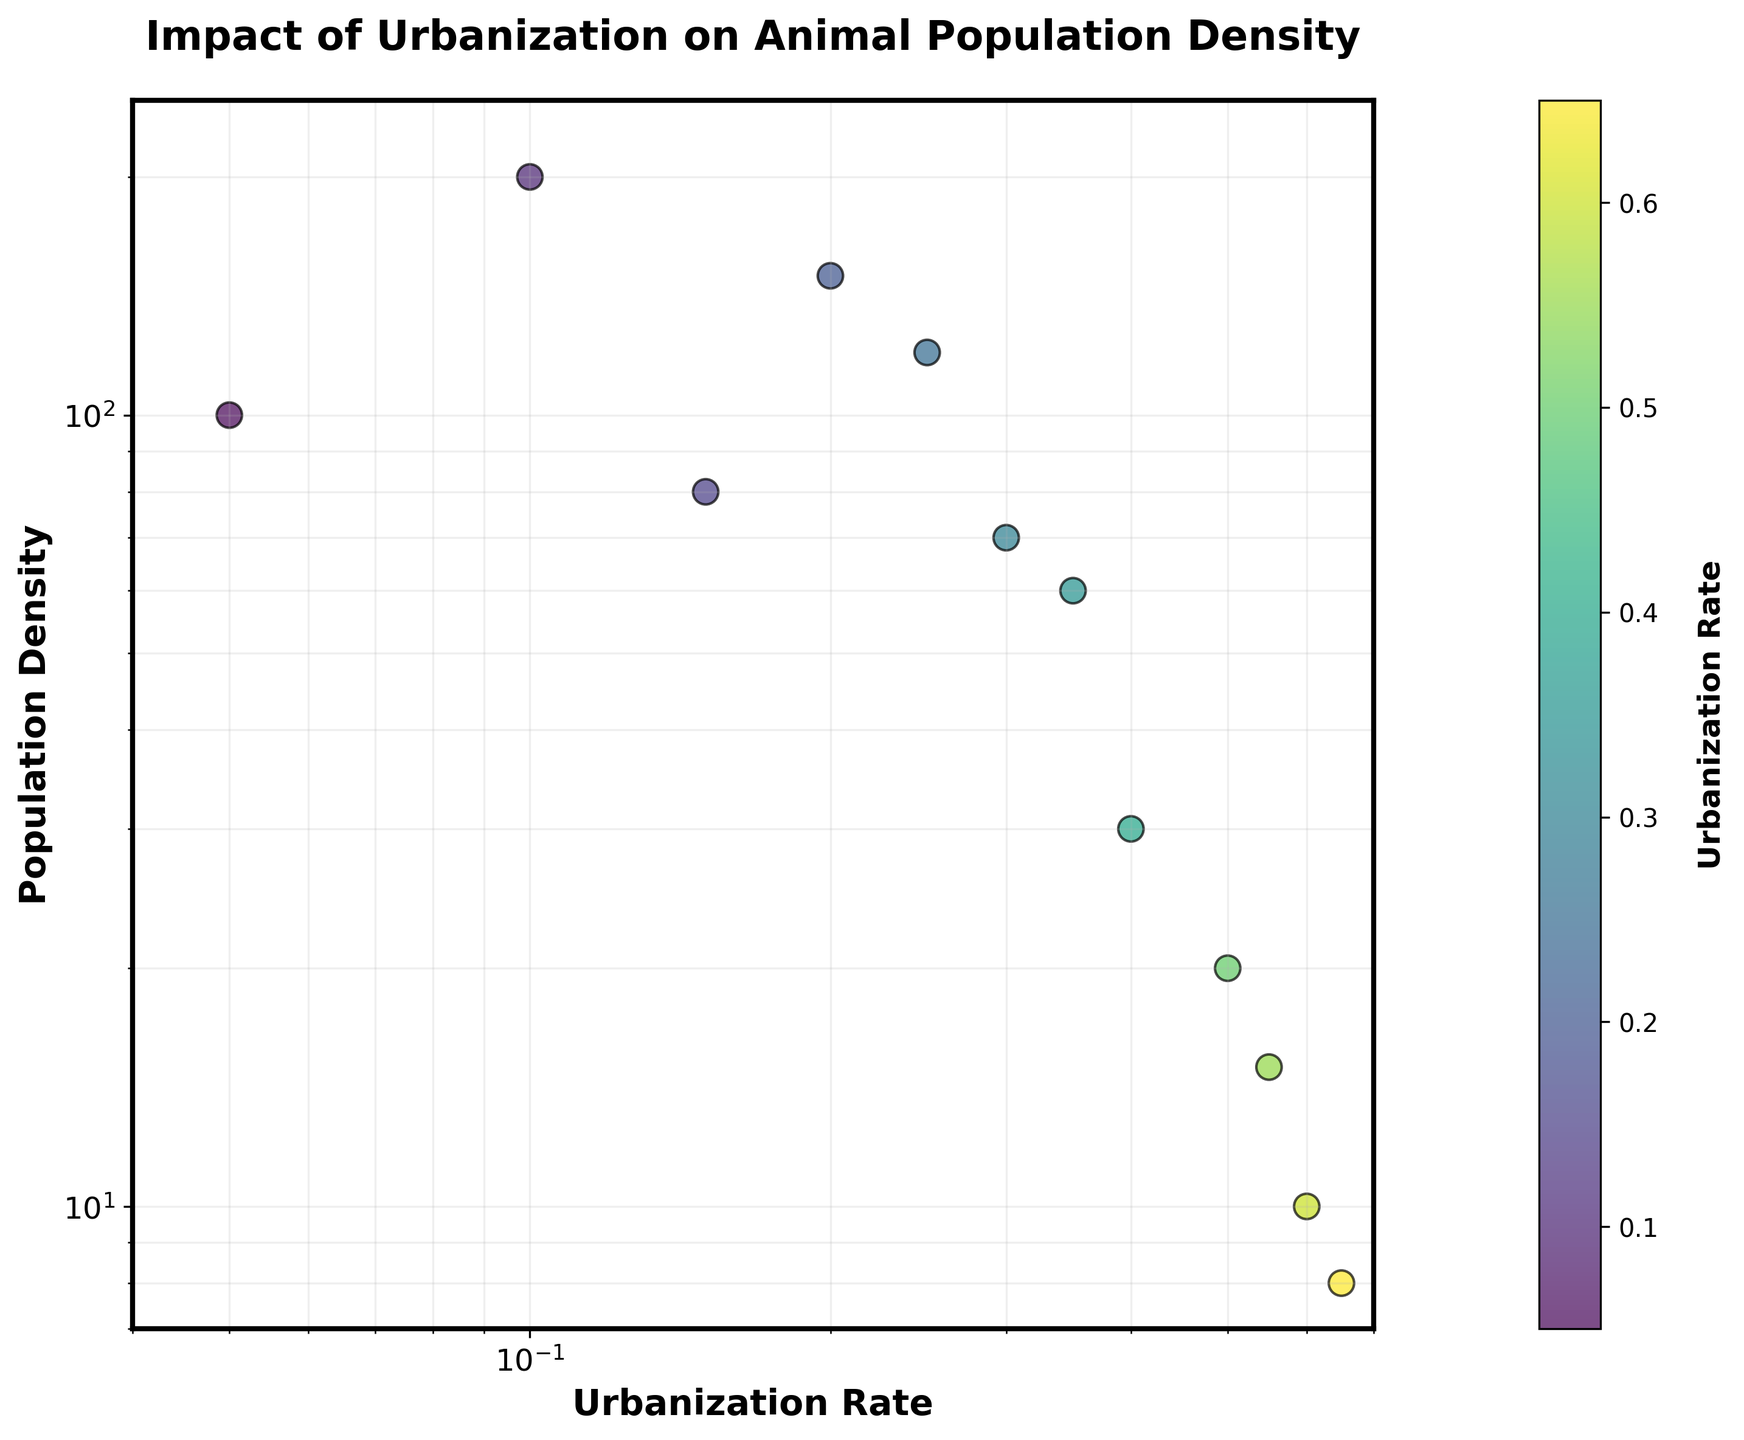What is the title of the plot? The title of the plot is located at the top center and reads "Impact of Urbanization on Animal Population Density."
Answer: "Impact of Urbanization on Animal Population Density" What is the x-axis label? The label on the x-axis is placed horizontally below the axis and reads "Urbanization Rate".
Answer: "Urbanization Rate" How many data points are represented in the scatter plot? To determine the number of data points, count each unique marker on the scatter plot. There are 12 data points represented.
Answer: 12 Which data point has the highest population density, and what is its urbanization rate? Look at the y-axis to find the highest population density, which is 200. Then, trace vertically downward to find the corresponding urbanization rate, which is 0.1.
Answer: Highest population density: 200, Urbanization rate: 0.1 Which data point has the lowest urbanization rate, and what is its population density? The lowest urbanization rate on the x-axis is 0.05. Trace vertically upward to find its corresponding population density, which is 100.
Answer: Lowest urbanization rate: 0.05, Population density: 100 Is there a visible trend between urbanization rates and population densities? The plot shows that as urbanization rates increase, population densities generally decrease. This is shown by the downward scattering of points from left to right.
Answer: Population densities decrease with increasing urbanization rates What is the population density at an urbanization rate of 0.3? Locate the urbanization rate of 0.3 on the x-axis and trace vertically to the corresponding data point on the plot, which indicates a population density of 70.
Answer: 70 Compare the population densities for urbanization rates of 0.2 and 0.25. Which is higher? Locate the urbanization rates of 0.2 and 0.25 on the x-axis. The corresponding population densities are 150 and 120, respectively. The population density at 0.2 is higher.
Answer: 150 at 0.2 is higher than 120 at 0.25 What population density range is represented in the plot? On the y-axis, identify the lowest and highest values among the data points. The population densities range from 8 to 200.
Answer: 8 to 200 What is the median population density of the data points shown? First, list the population densities in ascending order: 8, 10, 15, 20, 30, 60, 70, 80, 100, 120, 150, 200. With 12 data points, the median is the average of the 6th and 7th values: (60 + 70) / 2 = 65
Answer: 65 